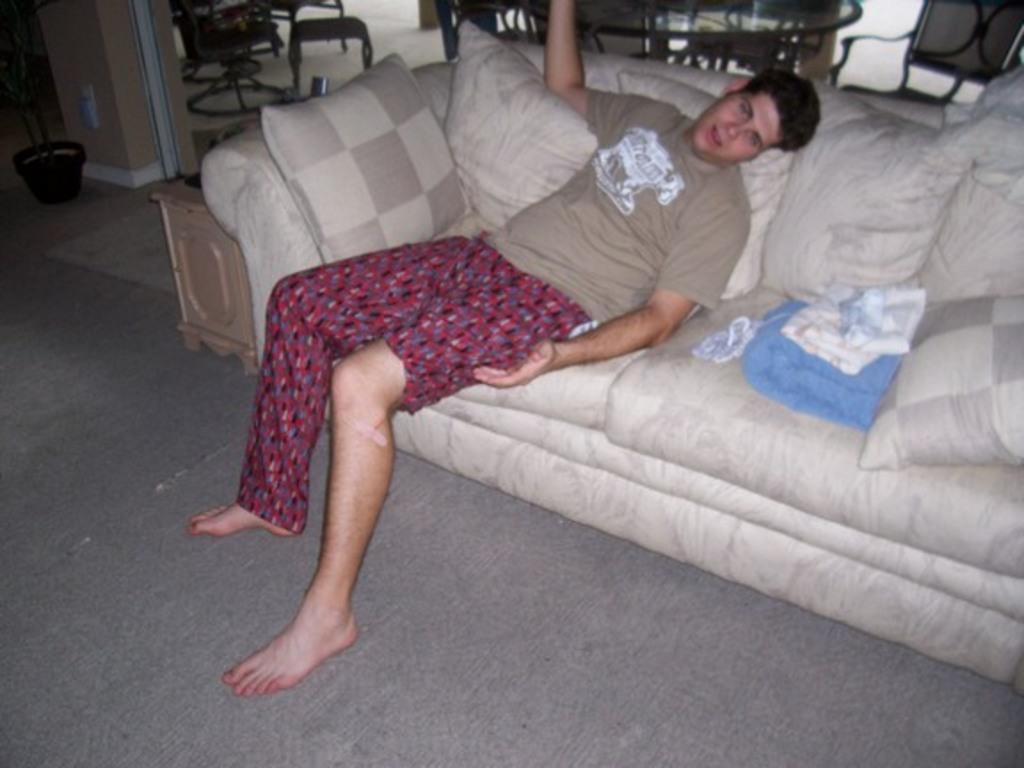Please provide a concise description of this image. This person sitting on the sofa and we can pillows on the sofa. On the background we can see chairs and table and we can see house plant on the floor. 